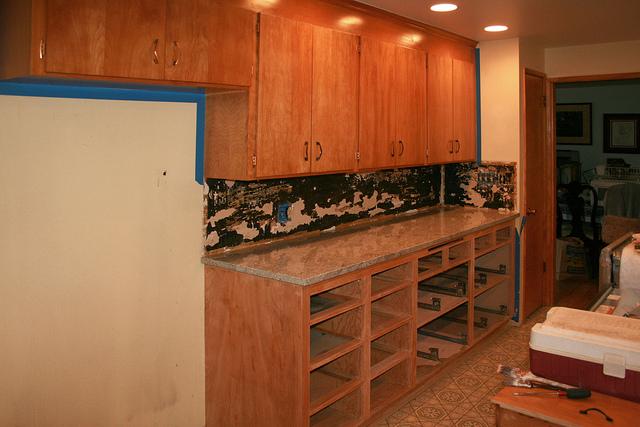What color is the tape on the left?
Keep it brief. Blue. What is missing on the lower cabinets?
Quick response, please. Drawers. How many cabinet locks are there?
Short answer required. 0. What color are the drawers?
Answer briefly. Brown. Is there any sofa in the room?
Concise answer only. No. Is this kitchen clean?
Answer briefly. Yes. 